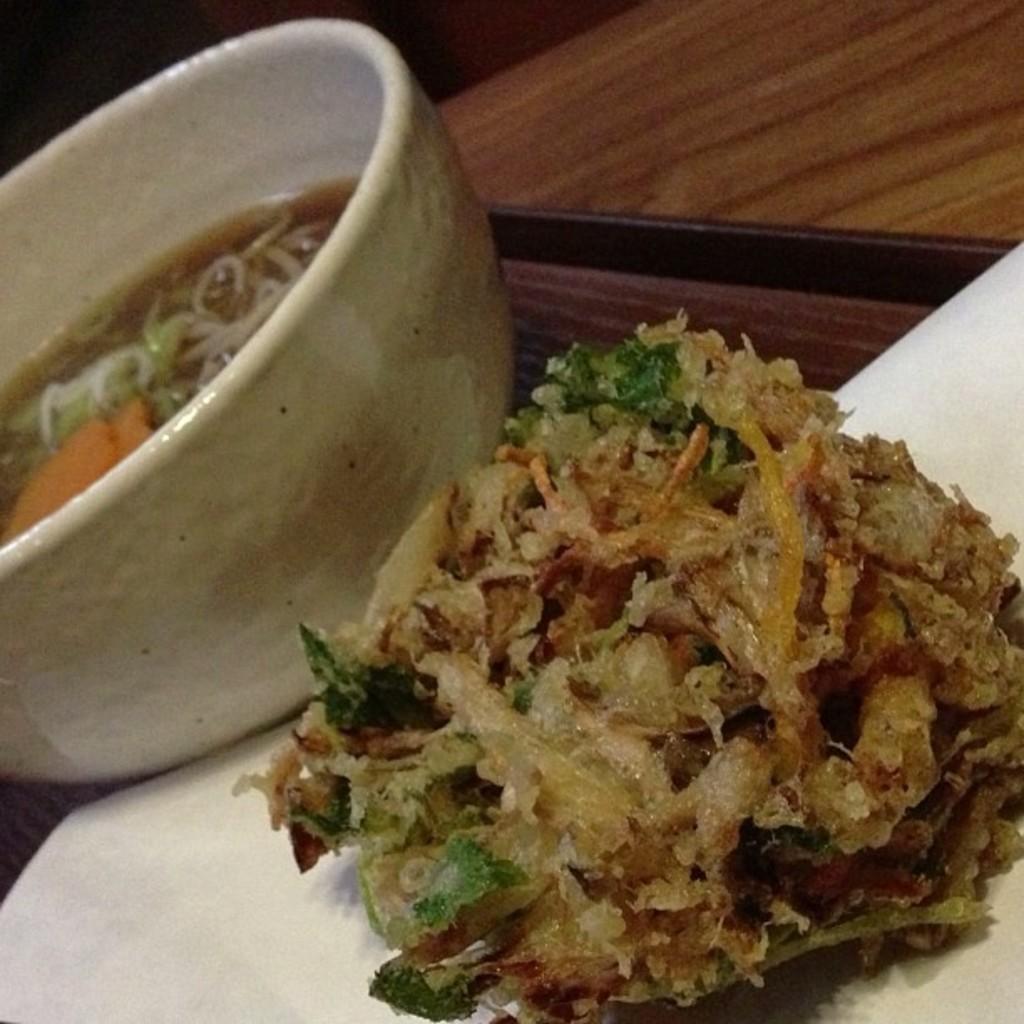How would you summarize this image in a sentence or two? In the center of the image we can see soup in bowl and food in plate placed on the table. 